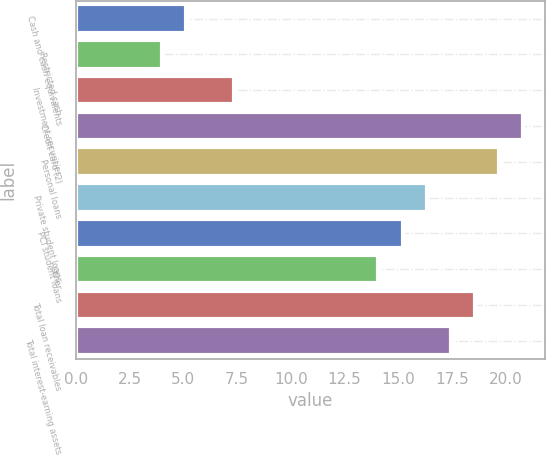Convert chart to OTSL. <chart><loc_0><loc_0><loc_500><loc_500><bar_chart><fcel>Cash and cash equivalents<fcel>Restricted cash<fcel>Investment securities<fcel>Credit card (2)<fcel>Personal loans<fcel>Private student loans<fcel>PCI student loans<fcel>Other<fcel>Total loan receivables<fcel>Total interest-earning assets<nl><fcel>5.12<fcel>4<fcel>7.36<fcel>20.8<fcel>19.68<fcel>16.32<fcel>15.2<fcel>14.08<fcel>18.56<fcel>17.44<nl></chart> 